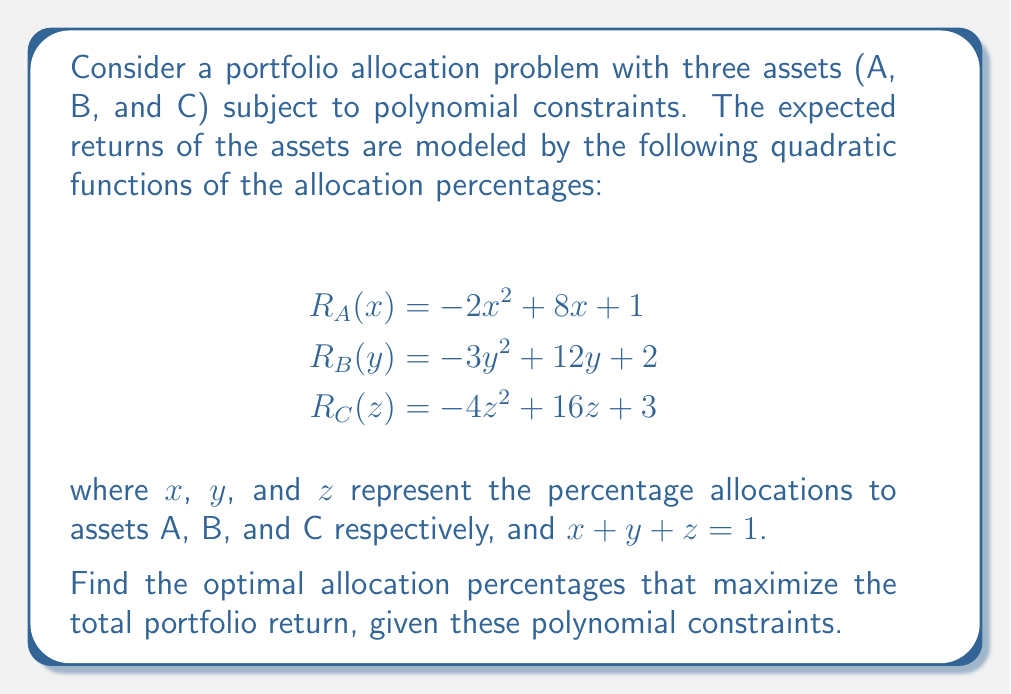Provide a solution to this math problem. To solve this portfolio optimization problem with polynomial constraints, we'll follow these steps:

1) First, we need to express the total portfolio return as a function of $x$ and $y$, since $z = 1 - x - y$:

   $R_{total}(x,y) = R_A(x) + R_B(y) + R_C(1-x-y)$

2) Expand this expression:

   $R_{total}(x,y) = (-2x^2 + 8x + 1) + (-3y^2 + 12y + 2) + [-4(1-x-y)^2 + 16(1-x-y) + 3]$

3) Simplify the last term:

   $-4(1-x-y)^2 + 16(1-x-y) + 3 = -4(1-2x-2y+x^2+2xy+y^2) + 16 - 16x - 16y + 3$
                                 $= -4 + 8x + 8y - 4x^2 - 8xy - 4y^2 + 16 - 16x - 16y + 3$
                                 $= -4x^2 - 8xy - 4y^2 - 8x - 8y + 15$

4) Now our total return function is:

   $R_{total}(x,y) = (-2x^2 + 8x + 1) + (-3y^2 + 12y + 2) + (-4x^2 - 8xy - 4y^2 - 8x - 8y + 15)$

5) Simplify:

   $R_{total}(x,y) = -6x^2 - 8xy - 7y^2 + 0x + 4y + 18$

6) To find the maximum, we need to find where the partial derivatives are zero:

   $\frac{\partial R}{\partial x} = -12x - 8y = 0$
   $\frac{\partial R}{\partial y} = -8x - 14y + 4 = 0$

7) Solve this system of equations:

   From the first equation: $x = -\frac{2}{3}y$
   
   Substitute into the second equation:
   
   $-8(-\frac{2}{3}y) - 14y + 4 = 0$
   $\frac{16}{3}y - 14y + 4 = 0$
   $-\frac{26}{3}y + 4 = 0$
   $y = \frac{6}{13}$

   Then $x = -\frac{2}{3} \cdot \frac{6}{13} = -\frac{4}{13}$

   And $z = 1 - x - y = 1 + \frac{4}{13} - \frac{6}{13} = \frac{11}{13}$

8) Verify that this is indeed a maximum by checking the second derivatives (omitted for brevity).

Therefore, the optimal allocation is approximately 30.77% to asset A, 46.15% to asset B, and 23.08% to asset C.
Answer: The optimal allocation percentages that maximize the total portfolio return are:

Asset A: $x = \frac{4}{13} \approx 30.77\%$
Asset B: $y = \frac{6}{13} \approx 46.15\%$
Asset C: $z = \frac{11}{13} \approx 23.08\%$ 